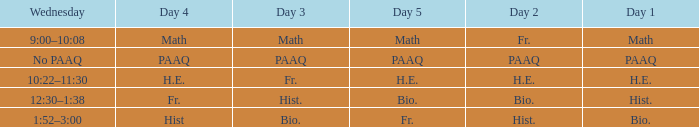What is the day 3 when day 4 is fr.? Hist. 